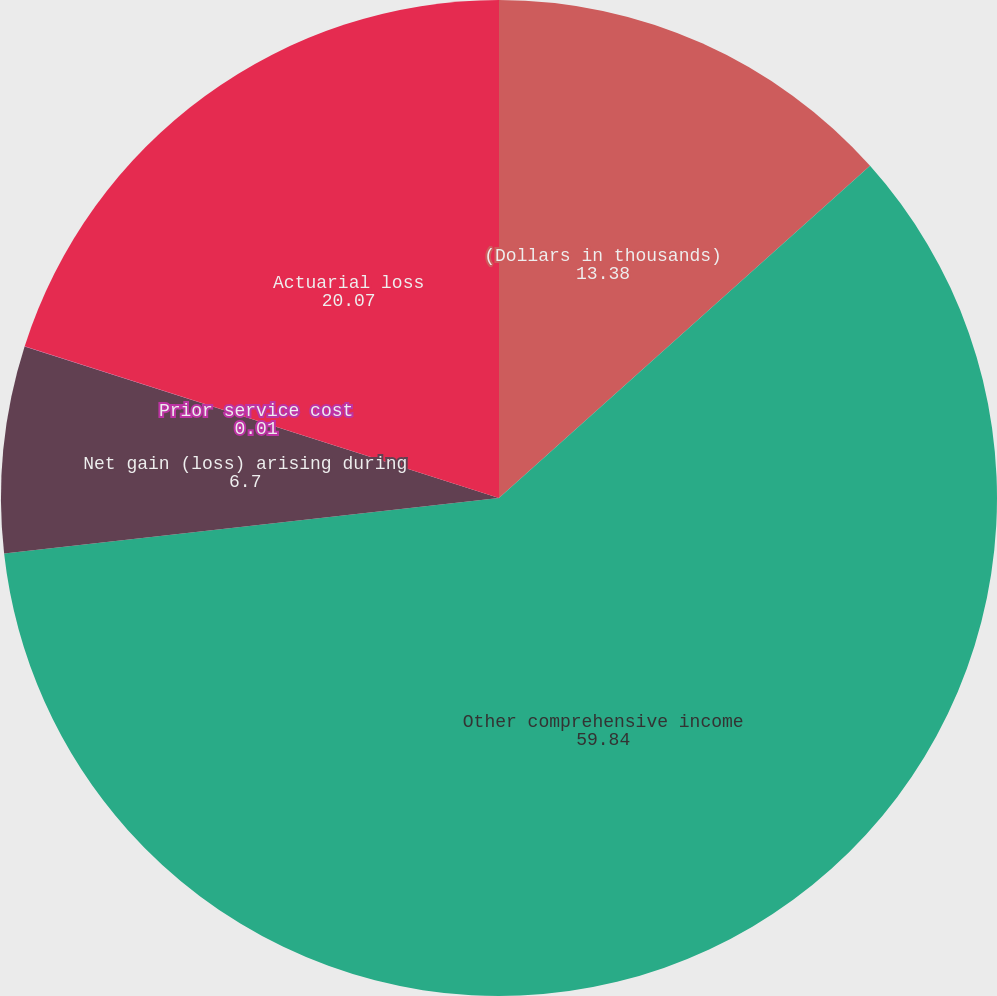Convert chart. <chart><loc_0><loc_0><loc_500><loc_500><pie_chart><fcel>(Dollars in thousands)<fcel>Other comprehensive income<fcel>Net gain (loss) arising during<fcel>Prior service cost<fcel>Actuarial loss<nl><fcel>13.38%<fcel>59.84%<fcel>6.7%<fcel>0.01%<fcel>20.07%<nl></chart> 